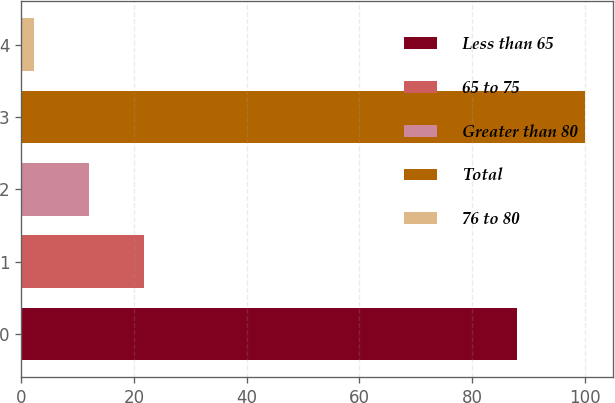Convert chart to OTSL. <chart><loc_0><loc_0><loc_500><loc_500><bar_chart><fcel>Less than 65<fcel>65 to 75<fcel>Greater than 80<fcel>Total<fcel>76 to 80<nl><fcel>88<fcel>21.76<fcel>11.98<fcel>100<fcel>2.2<nl></chart> 